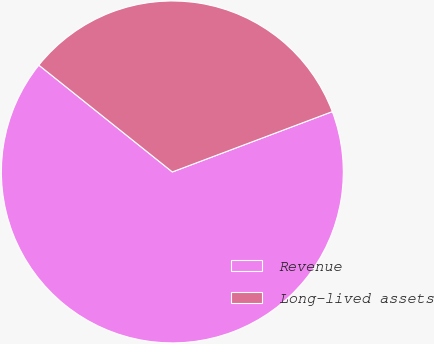<chart> <loc_0><loc_0><loc_500><loc_500><pie_chart><fcel>Revenue<fcel>Long-lived assets<nl><fcel>66.48%<fcel>33.52%<nl></chart> 